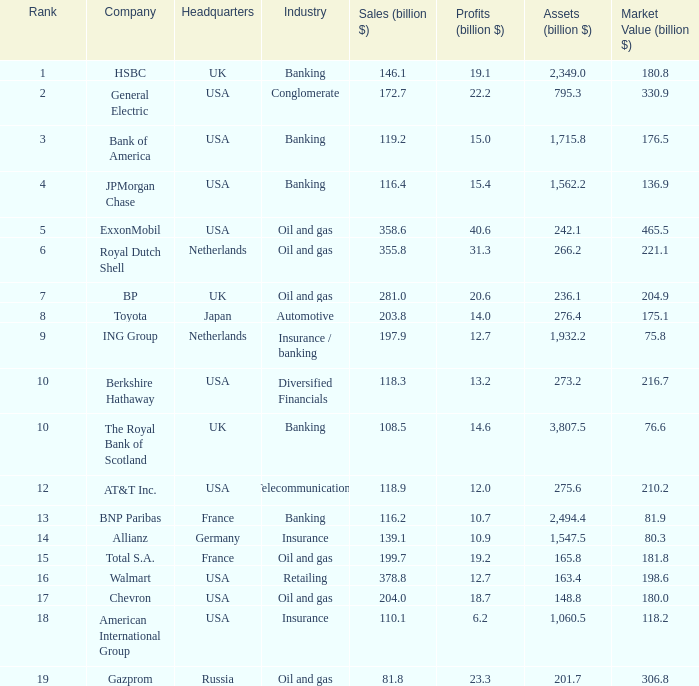Which industry has a company with a market value of 80.3 billion?  Insurance. 